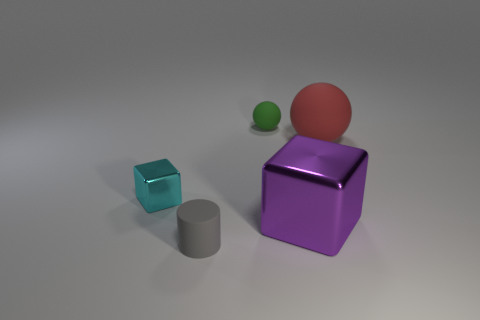What size is the rubber thing that is right of the object behind the big red object?
Provide a succinct answer. Large. There is a tiny thing left of the rubber cylinder; does it have the same shape as the large object behind the small cyan cube?
Give a very brief answer. No. Are there the same number of cylinders that are behind the purple metal cube and large red spheres?
Provide a short and direct response. No. What color is the other rubber object that is the same shape as the large red thing?
Provide a succinct answer. Green. Are the sphere on the left side of the big metallic thing and the purple thing made of the same material?
Offer a very short reply. No. What number of small objects are brown rubber cylinders or rubber cylinders?
Provide a succinct answer. 1. How big is the cyan shiny thing?
Offer a terse response. Small. Does the purple object have the same size as the rubber ball behind the red matte ball?
Offer a very short reply. No. What number of cyan objects are either large metallic cubes or shiny blocks?
Offer a very short reply. 1. What number of cubes are there?
Offer a terse response. 2. 